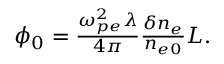Convert formula to latex. <formula><loc_0><loc_0><loc_500><loc_500>\begin{array} { r } { \phi _ { 0 } = \frac { \omega _ { p e } ^ { 2 } \lambda } { 4 \pi } \frac { \delta n _ { e } } { n _ { e 0 } } L . } \end{array}</formula> 